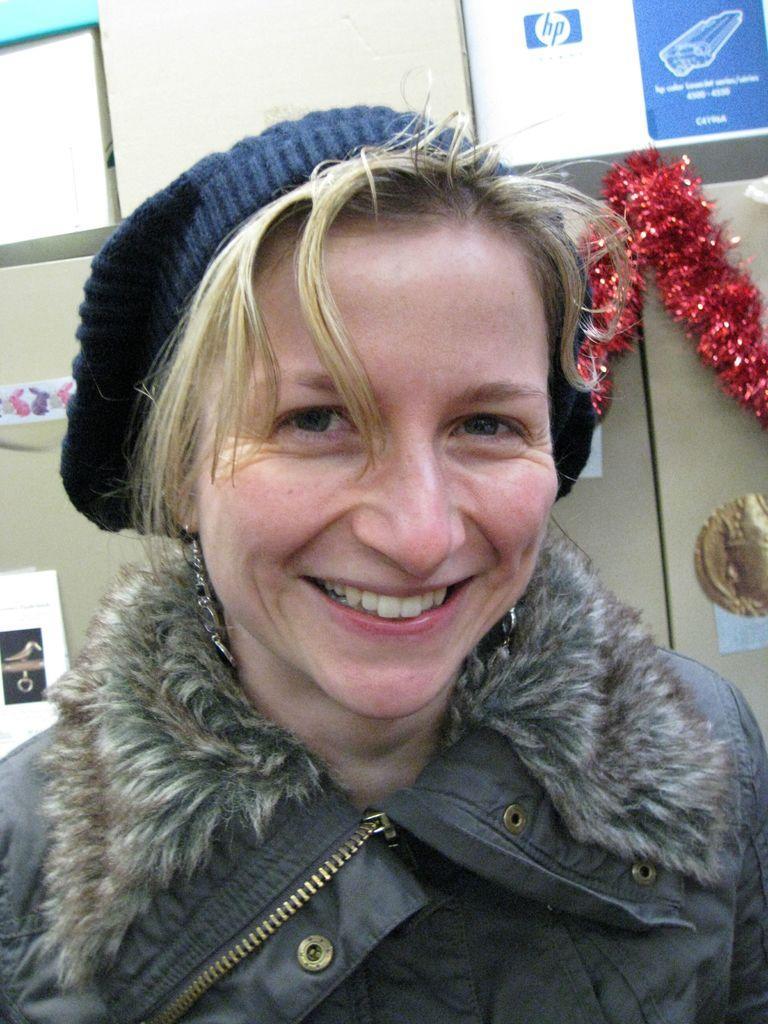Please provide a concise description of this image. In this image I can see a woman she is smiling and she wearing a cap in the background I can see the wall and I can see a decorative item attached to the wall 